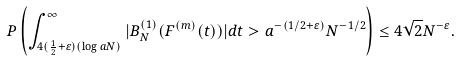Convert formula to latex. <formula><loc_0><loc_0><loc_500><loc_500>P \left ( \int _ { 4 ( \frac { 1 } { 2 } + \varepsilon ) ( \log a N ) } ^ { \infty } | B ^ { ( 1 ) } _ { N } ( F ^ { ( m ) } ( t ) ) | d t > a ^ { - ( 1 / 2 + \varepsilon ) } N ^ { - 1 / 2 } \right ) \leq 4 \sqrt { 2 } N ^ { - \varepsilon } .</formula> 